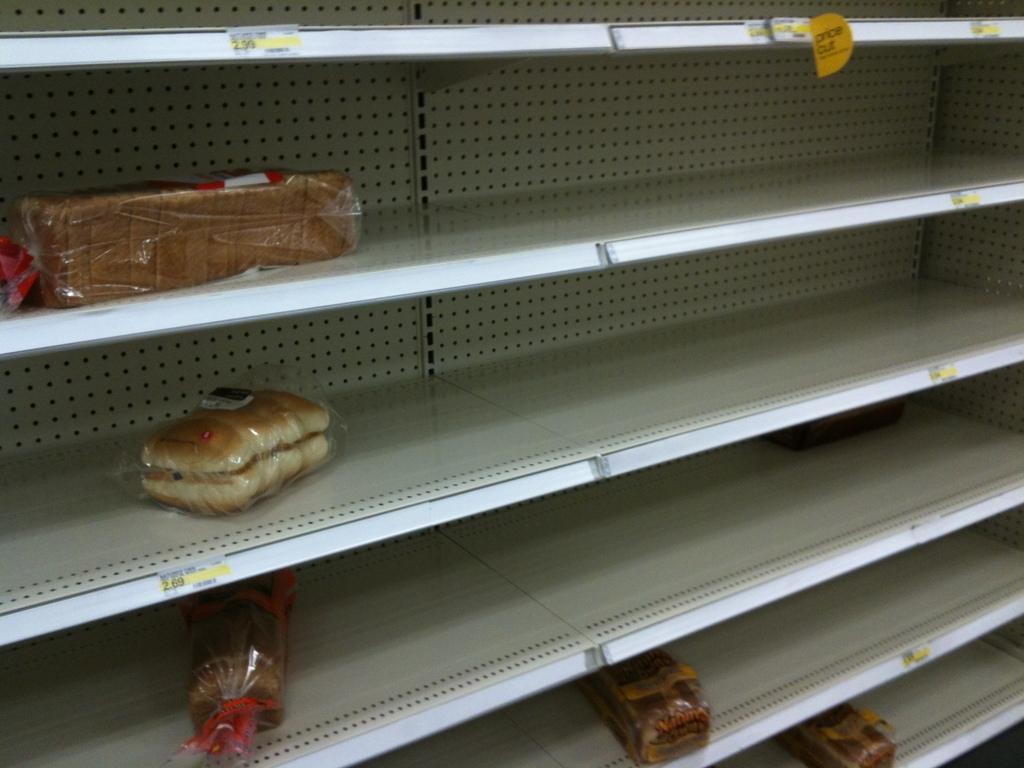What type of furniture is present in the image? There is a cupboard in the image. What items can be found inside the cupboard? There are breads and buns in the cupboard. What type of sticks are used to flavor the buns in the image? There is no mention of sticks or flavoring in the image; it only shows breads and buns inside a cupboard. 